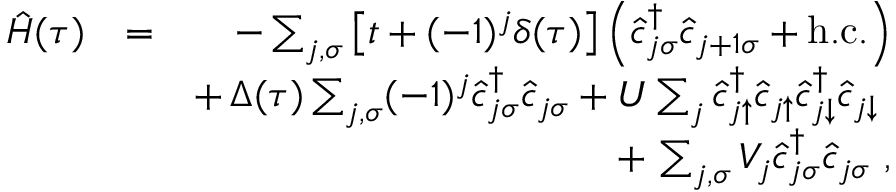Convert formula to latex. <formula><loc_0><loc_0><loc_500><loc_500>\begin{array} { r l r } { \hat { H } ( \tau ) } & { = } & { - \sum _ { j , \sigma } \left [ t + ( - 1 ) ^ { j } \delta ( \tau ) \right ] \left ( \hat { c } _ { j \sigma } ^ { \dagger } \hat { c } _ { j + 1 \sigma } + h . c . \right ) } \\ & { + \, \Delta ( \tau ) \sum _ { j , \sigma } ( - 1 ) ^ { j } \hat { c } _ { j \sigma } ^ { \dagger } \hat { c } _ { j \sigma } + U \sum _ { j } \hat { c } _ { j \uparrow } ^ { \dagger } \hat { c } _ { j \uparrow } \hat { c } _ { j \downarrow } ^ { \dagger } \hat { c } _ { j \downarrow } } \\ & { + \, \sum _ { j , \sigma } V _ { j } \hat { c } _ { j \sigma } ^ { \dagger } \hat { c } _ { j \sigma } , } \end{array}</formula> 